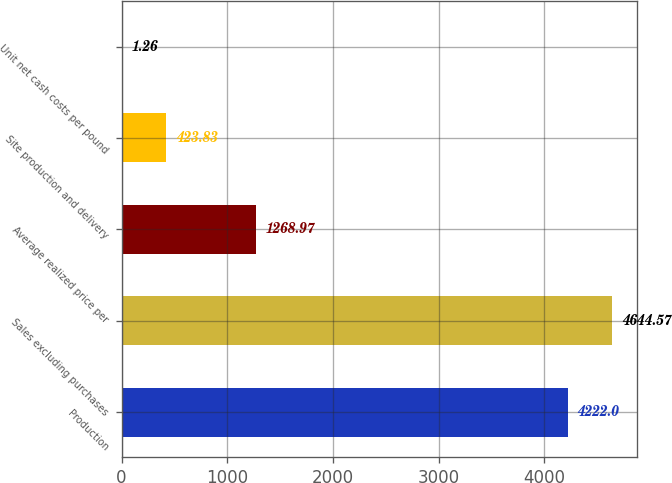Convert chart to OTSL. <chart><loc_0><loc_0><loc_500><loc_500><bar_chart><fcel>Production<fcel>Sales excluding purchases<fcel>Average realized price per<fcel>Site production and delivery<fcel>Unit net cash costs per pound<nl><fcel>4222<fcel>4644.57<fcel>1268.97<fcel>423.83<fcel>1.26<nl></chart> 